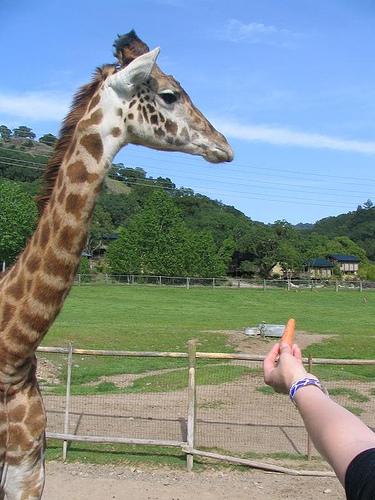Is there a metal building in the picture?
Answer briefly. No. How many giraffes are shown?
Give a very brief answer. 1. Where is the elephant looking?
Give a very brief answer. No elephant. Is there a house in the picture?
Short answer required. Yes. Is there a tongue?
Write a very short answer. No. What is the person doing?
Answer briefly. Feeding giraffe. Is the giraffe planning to eat the carrot?
Answer briefly. Yes. How many horns are visible?
Short answer required. 1. 